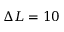Convert formula to latex. <formula><loc_0><loc_0><loc_500><loc_500>\Delta L = 1 0</formula> 